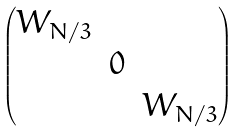Convert formula to latex. <formula><loc_0><loc_0><loc_500><loc_500>\begin{pmatrix} W _ { N / 3 } & & \\ & 0 & \\ & & W _ { N / 3 } \end{pmatrix}</formula> 